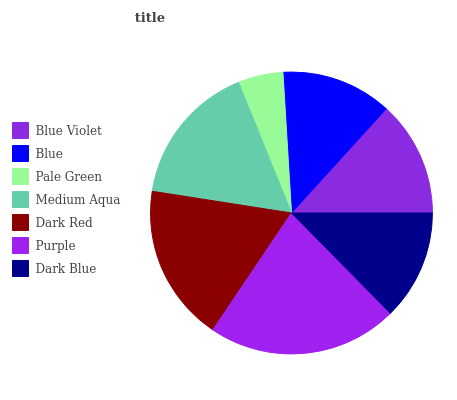Is Pale Green the minimum?
Answer yes or no. Yes. Is Purple the maximum?
Answer yes or no. Yes. Is Blue the minimum?
Answer yes or no. No. Is Blue the maximum?
Answer yes or no. No. Is Blue Violet greater than Blue?
Answer yes or no. Yes. Is Blue less than Blue Violet?
Answer yes or no. Yes. Is Blue greater than Blue Violet?
Answer yes or no. No. Is Blue Violet less than Blue?
Answer yes or no. No. Is Blue Violet the high median?
Answer yes or no. Yes. Is Blue Violet the low median?
Answer yes or no. Yes. Is Medium Aqua the high median?
Answer yes or no. No. Is Blue the low median?
Answer yes or no. No. 